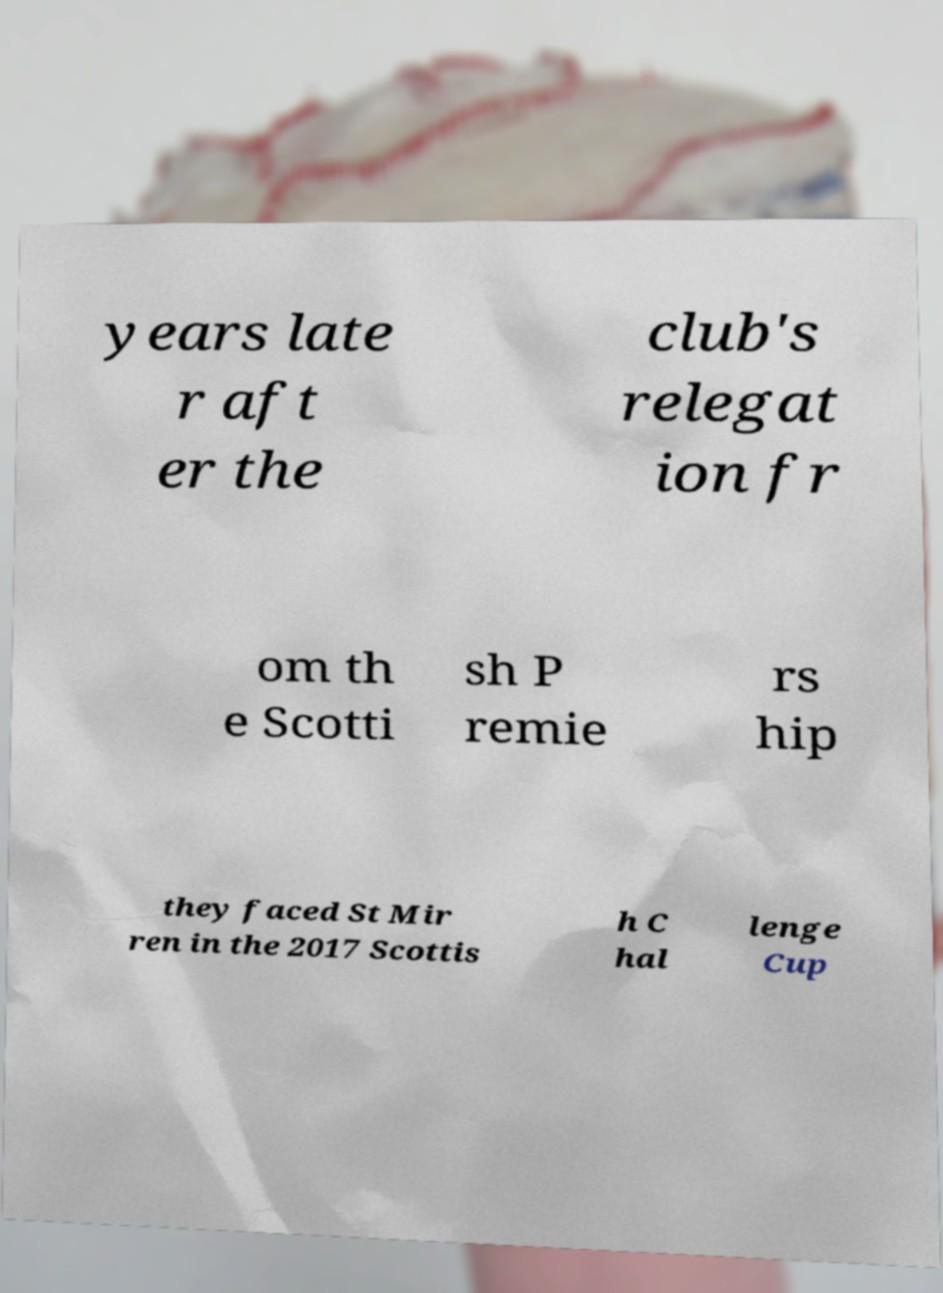What messages or text are displayed in this image? I need them in a readable, typed format. years late r aft er the club's relegat ion fr om th e Scotti sh P remie rs hip they faced St Mir ren in the 2017 Scottis h C hal lenge Cup 